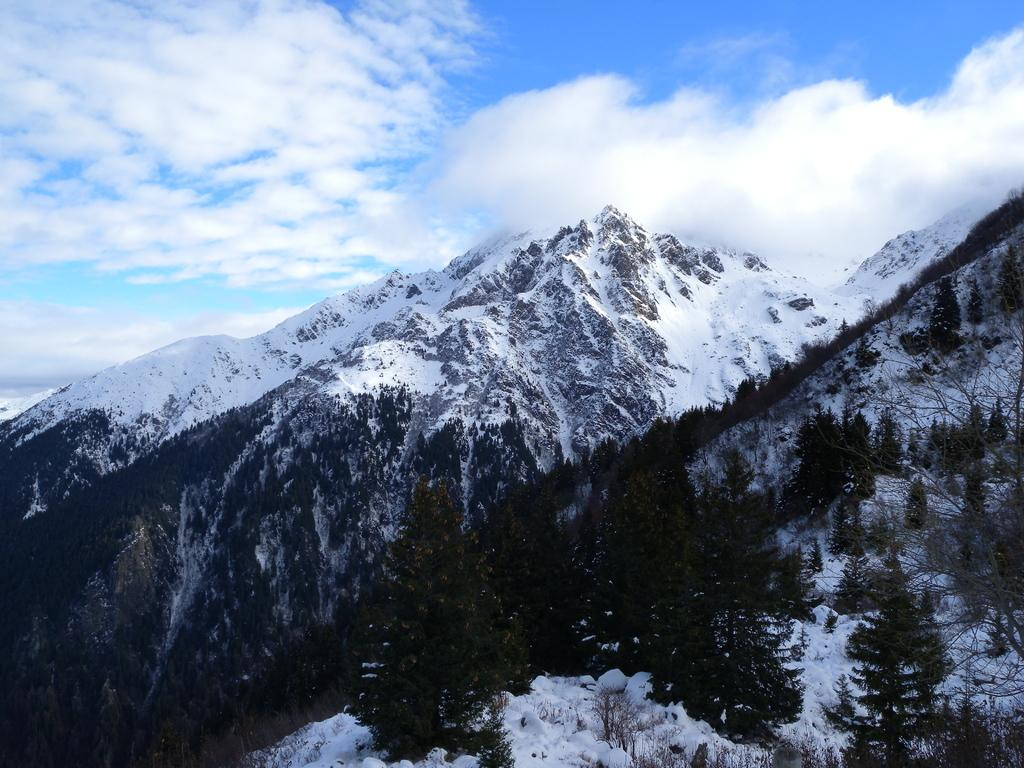What is the condition of the sky in the image? The sky is cloudy in the image. What can be seen on the mountain in the image? There are trees and snow on the mountain in the image. Can you see any monkeys climbing the trees on the mountain in the image? There are no monkeys present in the image; it only features trees and snow on the mountain. What type of need is being used to sew the snow on the mountain in the image? There is no sewing or needles present in the image; it simply shows snow on the mountain. 